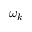<formula> <loc_0><loc_0><loc_500><loc_500>\omega _ { k }</formula> 